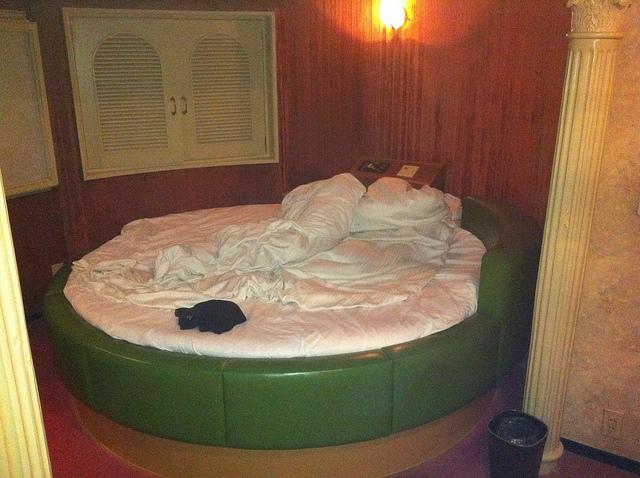Is the bed made in this picture?
Write a very short answer. No. What shape is the bed?
Answer briefly. Circle. What color is the bed?
Be succinct. Green. 